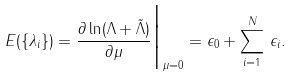<formula> <loc_0><loc_0><loc_500><loc_500>E ( \{ \lambda _ { i } \} ) = \frac { \partial \ln ( \Lambda + { \tilde { \Lambda } } ) } { \partial \mu } \Big | _ { \mu = 0 } = \epsilon _ { 0 } + \sum _ { i = 1 } ^ { N } \, \epsilon _ { i } .</formula> 